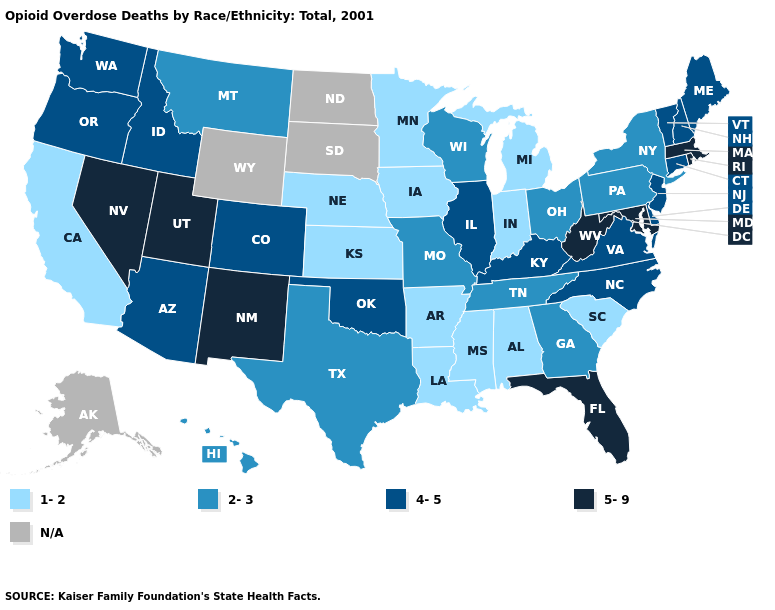What is the value of Idaho?
Answer briefly. 4-5. Among the states that border South Carolina , does North Carolina have the highest value?
Concise answer only. Yes. How many symbols are there in the legend?
Short answer required. 5. Does Arkansas have the lowest value in the South?
Quick response, please. Yes. Which states have the lowest value in the Northeast?
Keep it brief. New York, Pennsylvania. What is the value of California?
Quick response, please. 1-2. What is the value of Minnesota?
Keep it brief. 1-2. Name the states that have a value in the range 5-9?
Keep it brief. Florida, Maryland, Massachusetts, Nevada, New Mexico, Rhode Island, Utah, West Virginia. What is the lowest value in the South?
Concise answer only. 1-2. Does Colorado have the highest value in the USA?
Keep it brief. No. Is the legend a continuous bar?
Concise answer only. No. What is the value of New York?
Be succinct. 2-3. What is the value of North Carolina?
Quick response, please. 4-5. What is the highest value in the Northeast ?
Give a very brief answer. 5-9. Among the states that border Louisiana , does Arkansas have the lowest value?
Answer briefly. Yes. 